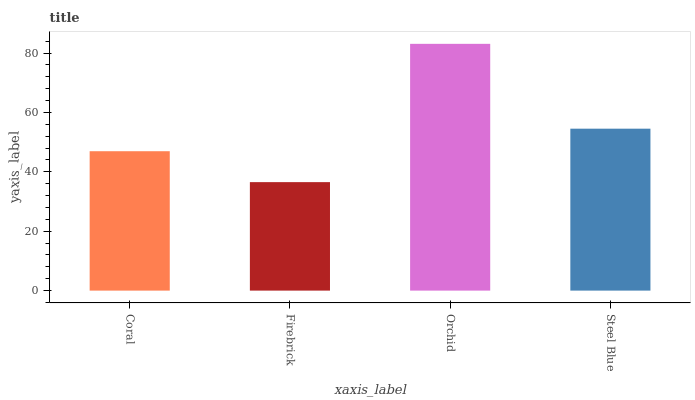Is Firebrick the minimum?
Answer yes or no. Yes. Is Orchid the maximum?
Answer yes or no. Yes. Is Orchid the minimum?
Answer yes or no. No. Is Firebrick the maximum?
Answer yes or no. No. Is Orchid greater than Firebrick?
Answer yes or no. Yes. Is Firebrick less than Orchid?
Answer yes or no. Yes. Is Firebrick greater than Orchid?
Answer yes or no. No. Is Orchid less than Firebrick?
Answer yes or no. No. Is Steel Blue the high median?
Answer yes or no. Yes. Is Coral the low median?
Answer yes or no. Yes. Is Firebrick the high median?
Answer yes or no. No. Is Firebrick the low median?
Answer yes or no. No. 